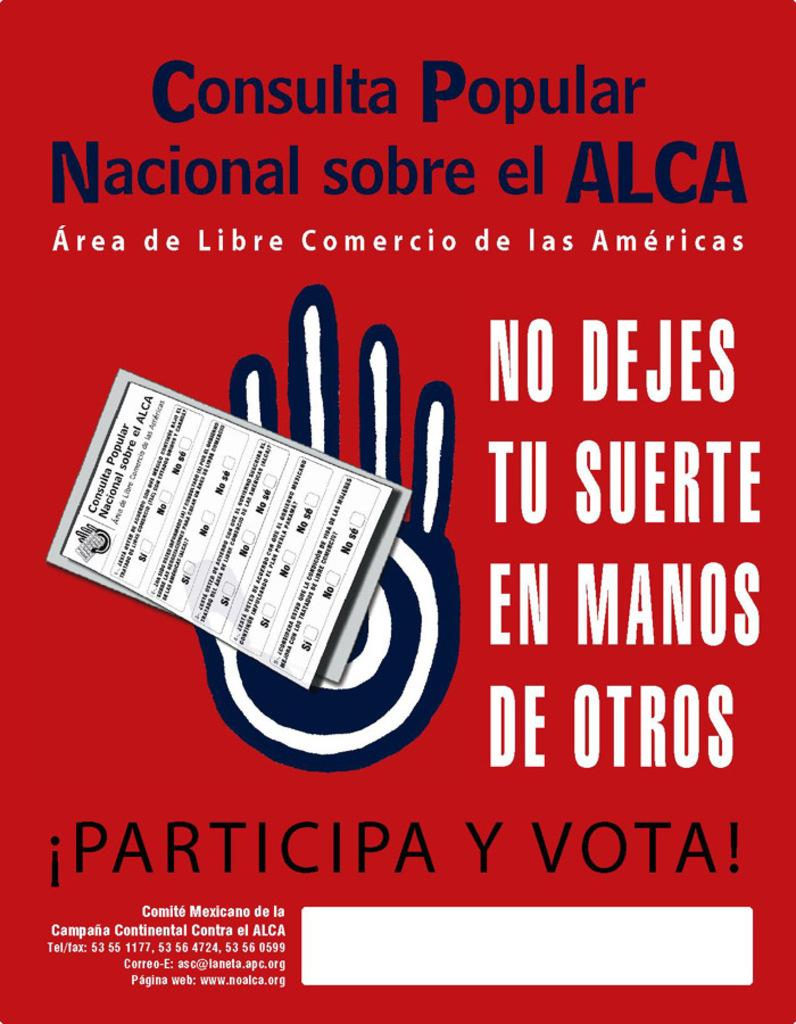<image>
Share a concise interpretation of the image provided. a red poster with a blue and white hand  reading !Particip Y Vota! 